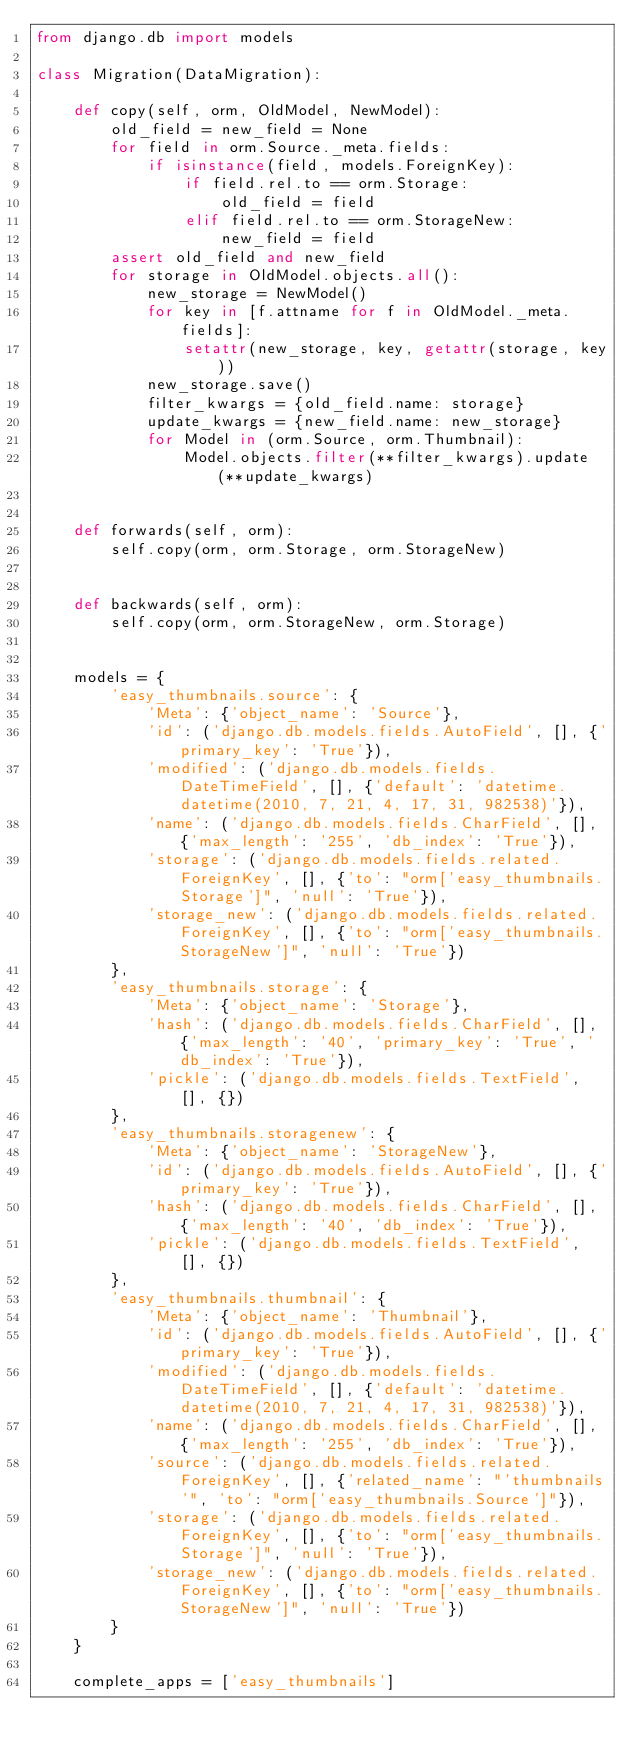Convert code to text. <code><loc_0><loc_0><loc_500><loc_500><_Python_>from django.db import models

class Migration(DataMigration):

    def copy(self, orm, OldModel, NewModel):
        old_field = new_field = None
        for field in orm.Source._meta.fields:
            if isinstance(field, models.ForeignKey):
                if field.rel.to == orm.Storage:
                    old_field = field
                elif field.rel.to == orm.StorageNew:
                    new_field = field
        assert old_field and new_field
        for storage in OldModel.objects.all():
            new_storage = NewModel()
            for key in [f.attname for f in OldModel._meta.fields]:
                setattr(new_storage, key, getattr(storage, key))
            new_storage.save()
            filter_kwargs = {old_field.name: storage}
            update_kwargs = {new_field.name: new_storage}
            for Model in (orm.Source, orm.Thumbnail):
                Model.objects.filter(**filter_kwargs).update(**update_kwargs)
    
    
    def forwards(self, orm):
        self.copy(orm, orm.Storage, orm.StorageNew)


    def backwards(self, orm):
        self.copy(orm, orm.StorageNew, orm.Storage)


    models = {
        'easy_thumbnails.source': {
            'Meta': {'object_name': 'Source'},
            'id': ('django.db.models.fields.AutoField', [], {'primary_key': 'True'}),
            'modified': ('django.db.models.fields.DateTimeField', [], {'default': 'datetime.datetime(2010, 7, 21, 4, 17, 31, 982538)'}),
            'name': ('django.db.models.fields.CharField', [], {'max_length': '255', 'db_index': 'True'}),
            'storage': ('django.db.models.fields.related.ForeignKey', [], {'to': "orm['easy_thumbnails.Storage']", 'null': 'True'}),
            'storage_new': ('django.db.models.fields.related.ForeignKey', [], {'to': "orm['easy_thumbnails.StorageNew']", 'null': 'True'})
        },
        'easy_thumbnails.storage': {
            'Meta': {'object_name': 'Storage'},
            'hash': ('django.db.models.fields.CharField', [], {'max_length': '40', 'primary_key': 'True', 'db_index': 'True'}),
            'pickle': ('django.db.models.fields.TextField', [], {})
        },
        'easy_thumbnails.storagenew': {
            'Meta': {'object_name': 'StorageNew'},
            'id': ('django.db.models.fields.AutoField', [], {'primary_key': 'True'}),
            'hash': ('django.db.models.fields.CharField', [], {'max_length': '40', 'db_index': 'True'}),
            'pickle': ('django.db.models.fields.TextField', [], {})
        },
        'easy_thumbnails.thumbnail': {
            'Meta': {'object_name': 'Thumbnail'},
            'id': ('django.db.models.fields.AutoField', [], {'primary_key': 'True'}),
            'modified': ('django.db.models.fields.DateTimeField', [], {'default': 'datetime.datetime(2010, 7, 21, 4, 17, 31, 982538)'}),
            'name': ('django.db.models.fields.CharField', [], {'max_length': '255', 'db_index': 'True'}),
            'source': ('django.db.models.fields.related.ForeignKey', [], {'related_name': "'thumbnails'", 'to': "orm['easy_thumbnails.Source']"}),
            'storage': ('django.db.models.fields.related.ForeignKey', [], {'to': "orm['easy_thumbnails.Storage']", 'null': 'True'}),
            'storage_new': ('django.db.models.fields.related.ForeignKey', [], {'to': "orm['easy_thumbnails.StorageNew']", 'null': 'True'})
        }
    }

    complete_apps = ['easy_thumbnails']
</code> 